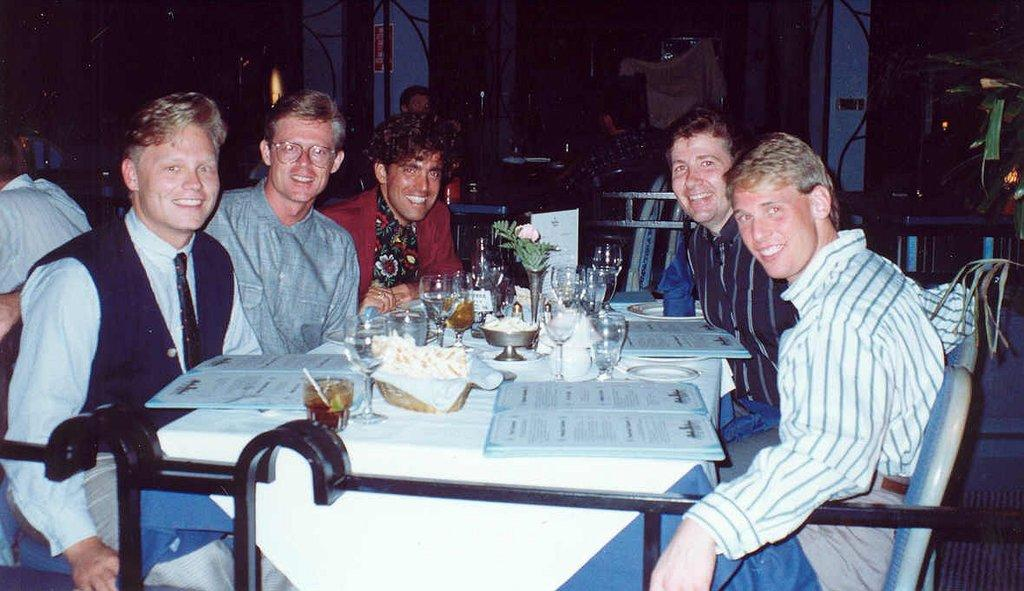Who or what can be seen in the image? There are people in the image. What are the people sitting on? There are chairs in the image. What is on the table in the image? There are groups of objects on a table in the image. What can be seen in the background of the image? There are two pillars in the background of the image. What type of amusement can be seen on the page in the image? There is no page or amusement present in the image. What is the texture of the objects on the table in the image? The provided facts do not mention the texture of the objects on the table, so it cannot be determined from the image. 